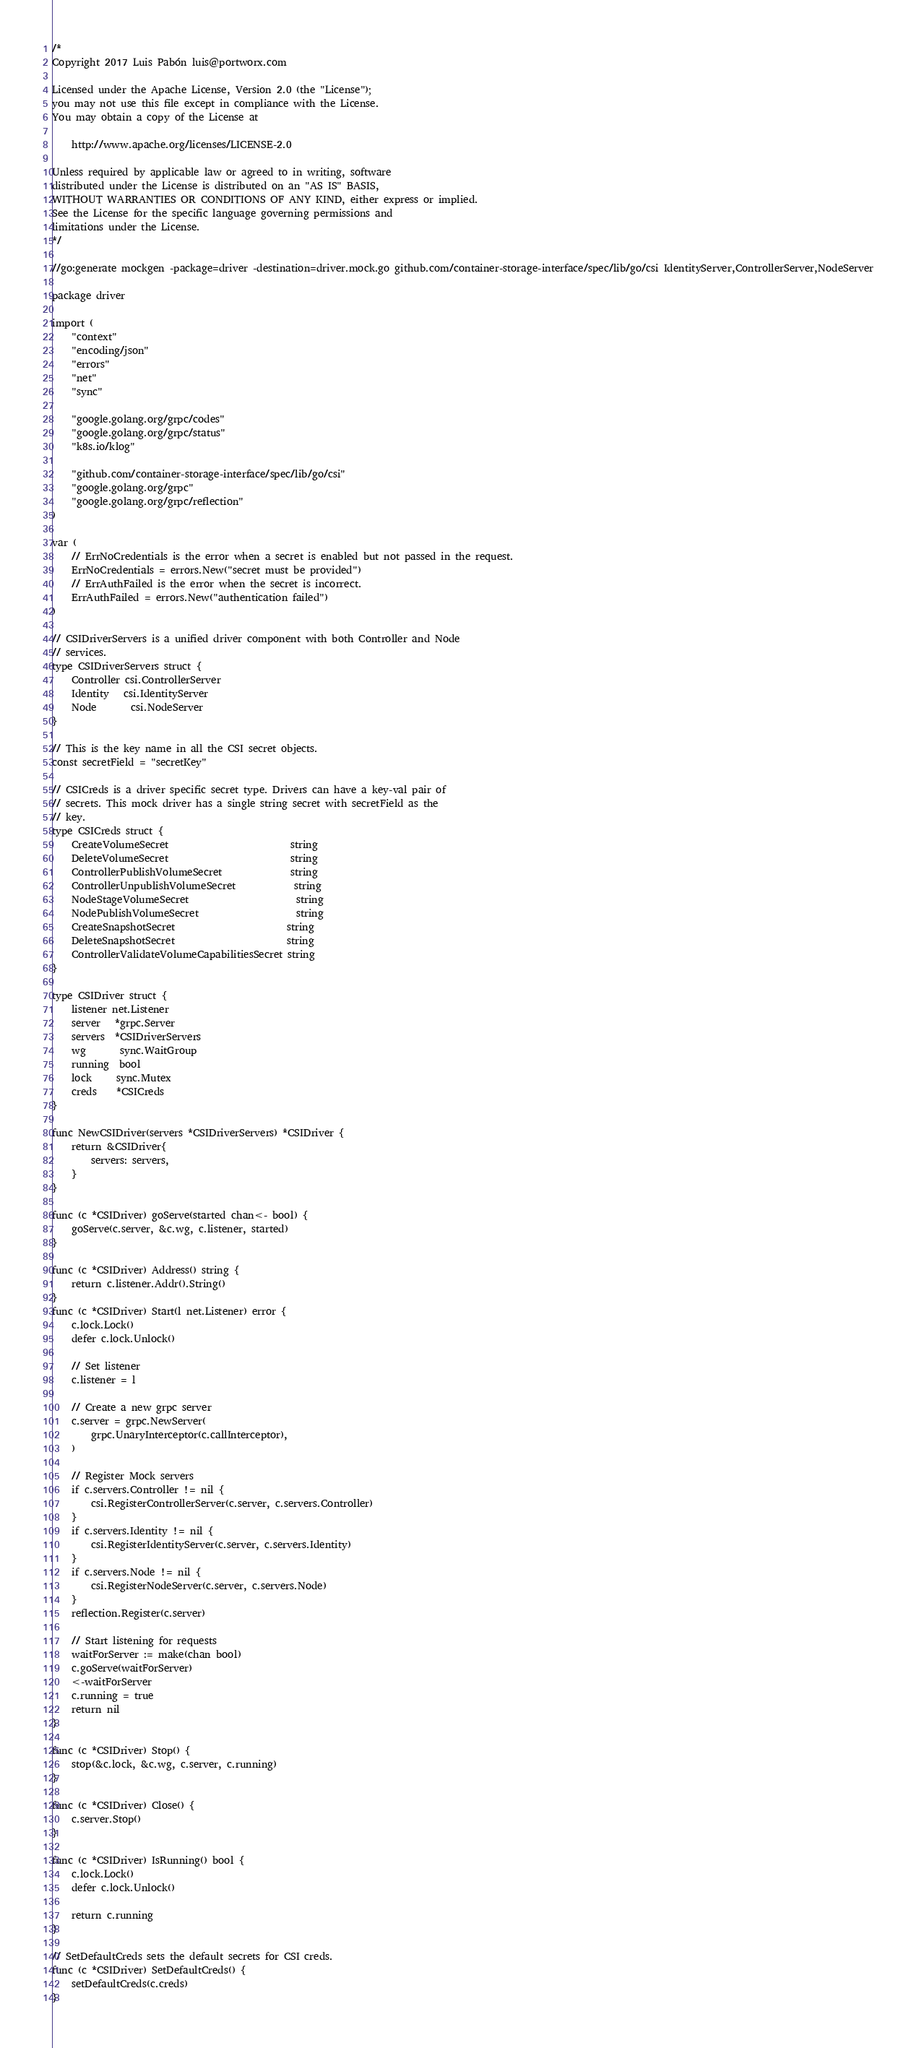<code> <loc_0><loc_0><loc_500><loc_500><_Go_>/*
Copyright 2017 Luis Pabón luis@portworx.com

Licensed under the Apache License, Version 2.0 (the "License");
you may not use this file except in compliance with the License.
You may obtain a copy of the License at

    http://www.apache.org/licenses/LICENSE-2.0

Unless required by applicable law or agreed to in writing, software
distributed under the License is distributed on an "AS IS" BASIS,
WITHOUT WARRANTIES OR CONDITIONS OF ANY KIND, either express or implied.
See the License for the specific language governing permissions and
limitations under the License.
*/

//go:generate mockgen -package=driver -destination=driver.mock.go github.com/container-storage-interface/spec/lib/go/csi IdentityServer,ControllerServer,NodeServer

package driver

import (
	"context"
	"encoding/json"
	"errors"
	"net"
	"sync"

	"google.golang.org/grpc/codes"
	"google.golang.org/grpc/status"
	"k8s.io/klog"

	"github.com/container-storage-interface/spec/lib/go/csi"
	"google.golang.org/grpc"
	"google.golang.org/grpc/reflection"
)

var (
	// ErrNoCredentials is the error when a secret is enabled but not passed in the request.
	ErrNoCredentials = errors.New("secret must be provided")
	// ErrAuthFailed is the error when the secret is incorrect.
	ErrAuthFailed = errors.New("authentication failed")
)

// CSIDriverServers is a unified driver component with both Controller and Node
// services.
type CSIDriverServers struct {
	Controller csi.ControllerServer
	Identity   csi.IdentityServer
	Node       csi.NodeServer
}

// This is the key name in all the CSI secret objects.
const secretField = "secretKey"

// CSICreds is a driver specific secret type. Drivers can have a key-val pair of
// secrets. This mock driver has a single string secret with secretField as the
// key.
type CSICreds struct {
	CreateVolumeSecret                         string
	DeleteVolumeSecret                         string
	ControllerPublishVolumeSecret              string
	ControllerUnpublishVolumeSecret            string
	NodeStageVolumeSecret                      string
	NodePublishVolumeSecret                    string
	CreateSnapshotSecret                       string
	DeleteSnapshotSecret                       string
	ControllerValidateVolumeCapabilitiesSecret string
}

type CSIDriver struct {
	listener net.Listener
	server   *grpc.Server
	servers  *CSIDriverServers
	wg       sync.WaitGroup
	running  bool
	lock     sync.Mutex
	creds    *CSICreds
}

func NewCSIDriver(servers *CSIDriverServers) *CSIDriver {
	return &CSIDriver{
		servers: servers,
	}
}

func (c *CSIDriver) goServe(started chan<- bool) {
	goServe(c.server, &c.wg, c.listener, started)
}

func (c *CSIDriver) Address() string {
	return c.listener.Addr().String()
}
func (c *CSIDriver) Start(l net.Listener) error {
	c.lock.Lock()
	defer c.lock.Unlock()

	// Set listener
	c.listener = l

	// Create a new grpc server
	c.server = grpc.NewServer(
		grpc.UnaryInterceptor(c.callInterceptor),
	)

	// Register Mock servers
	if c.servers.Controller != nil {
		csi.RegisterControllerServer(c.server, c.servers.Controller)
	}
	if c.servers.Identity != nil {
		csi.RegisterIdentityServer(c.server, c.servers.Identity)
	}
	if c.servers.Node != nil {
		csi.RegisterNodeServer(c.server, c.servers.Node)
	}
	reflection.Register(c.server)

	// Start listening for requests
	waitForServer := make(chan bool)
	c.goServe(waitForServer)
	<-waitForServer
	c.running = true
	return nil
}

func (c *CSIDriver) Stop() {
	stop(&c.lock, &c.wg, c.server, c.running)
}

func (c *CSIDriver) Close() {
	c.server.Stop()
}

func (c *CSIDriver) IsRunning() bool {
	c.lock.Lock()
	defer c.lock.Unlock()

	return c.running
}

// SetDefaultCreds sets the default secrets for CSI creds.
func (c *CSIDriver) SetDefaultCreds() {
	setDefaultCreds(c.creds)
}
</code> 